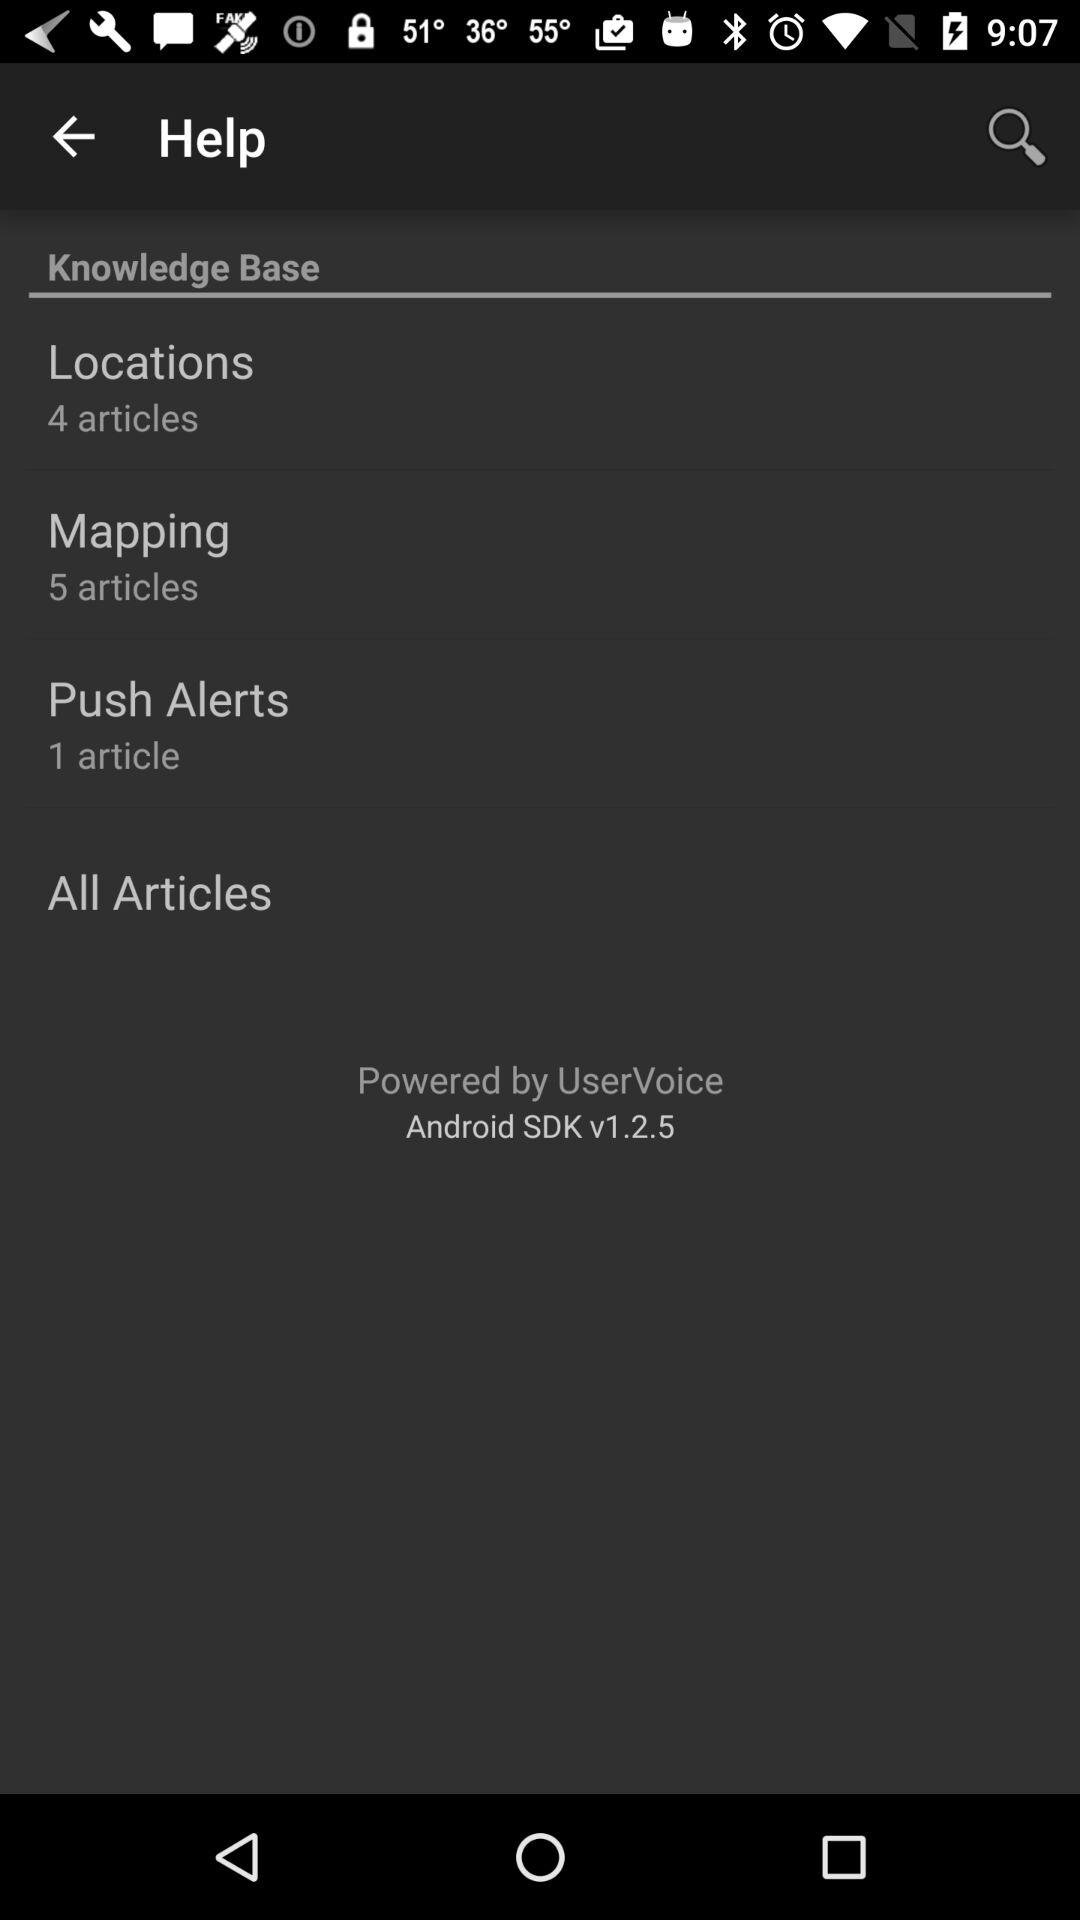How many articles are there in "Mapping"? There are 5 articles in "Mapping". 